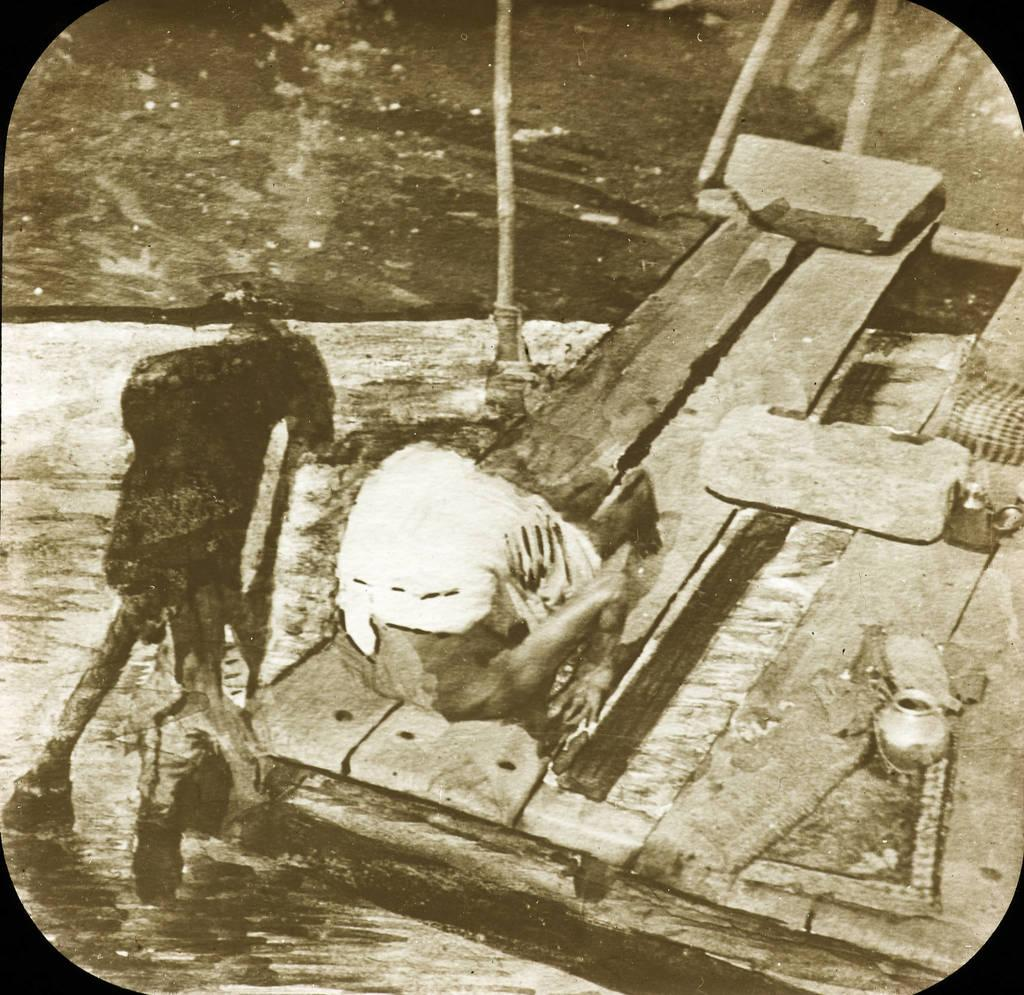What is the color scheme of the image? The image is a black and white photo. What type of boundary is visible in the image? There is no boundary visible in the image, as it is a black and white photo without any context or additional elements. 